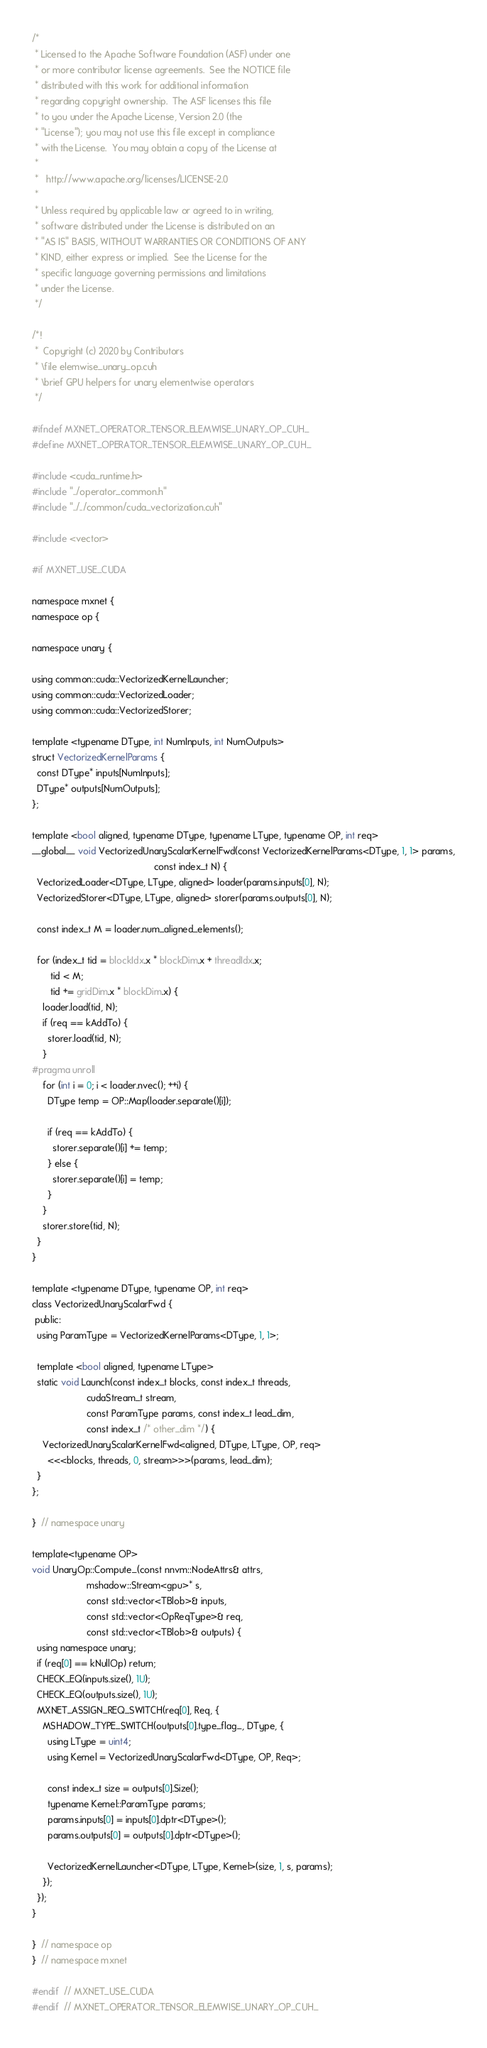Convert code to text. <code><loc_0><loc_0><loc_500><loc_500><_Cuda_>/*
 * Licensed to the Apache Software Foundation (ASF) under one
 * or more contributor license agreements.  See the NOTICE file
 * distributed with this work for additional information
 * regarding copyright ownership.  The ASF licenses this file
 * to you under the Apache License, Version 2.0 (the
 * "License"); you may not use this file except in compliance
 * with the License.  You may obtain a copy of the License at
 *
 *   http://www.apache.org/licenses/LICENSE-2.0
 *
 * Unless required by applicable law or agreed to in writing,
 * software distributed under the License is distributed on an
 * "AS IS" BASIS, WITHOUT WARRANTIES OR CONDITIONS OF ANY
 * KIND, either express or implied.  See the License for the
 * specific language governing permissions and limitations
 * under the License.
 */

/*!
 *  Copyright (c) 2020 by Contributors
 * \file elemwise_unary_op.cuh
 * \brief GPU helpers for unary elementwise operators
 */

#ifndef MXNET_OPERATOR_TENSOR_ELEMWISE_UNARY_OP_CUH_
#define MXNET_OPERATOR_TENSOR_ELEMWISE_UNARY_OP_CUH_

#include <cuda_runtime.h>
#include "../operator_common.h"
#include "../../common/cuda_vectorization.cuh"

#include <vector>

#if MXNET_USE_CUDA

namespace mxnet {
namespace op {

namespace unary {

using common::cuda::VectorizedKernelLauncher;
using common::cuda::VectorizedLoader;
using common::cuda::VectorizedStorer;

template <typename DType, int NumInputs, int NumOutputs>
struct VectorizedKernelParams {
  const DType* inputs[NumInputs];
  DType* outputs[NumOutputs];
};

template <bool aligned, typename DType, typename LType, typename OP, int req>
__global__ void VectorizedUnaryScalarKernelFwd(const VectorizedKernelParams<DType, 1, 1> params,
                                               const index_t N) {
  VectorizedLoader<DType, LType, aligned> loader(params.inputs[0], N);
  VectorizedStorer<DType, LType, aligned> storer(params.outputs[0], N);

  const index_t M = loader.num_aligned_elements();

  for (index_t tid = blockIdx.x * blockDim.x + threadIdx.x;
       tid < M;
       tid += gridDim.x * blockDim.x) {
    loader.load(tid, N);
    if (req == kAddTo) {
      storer.load(tid, N);
    }
#pragma unroll
    for (int i = 0; i < loader.nvec(); ++i) {
      DType temp = OP::Map(loader.separate()[i]);

      if (req == kAddTo) {
        storer.separate()[i] += temp;
      } else {
        storer.separate()[i] = temp;
      }
    }
    storer.store(tid, N);
  }
}

template <typename DType, typename OP, int req>
class VectorizedUnaryScalarFwd {
 public:
  using ParamType = VectorizedKernelParams<DType, 1, 1>;

  template <bool aligned, typename LType>
  static void Launch(const index_t blocks, const index_t threads,
                     cudaStream_t stream,
                     const ParamType params, const index_t lead_dim,
                     const index_t /* other_dim */) {
    VectorizedUnaryScalarKernelFwd<aligned, DType, LType, OP, req>
      <<<blocks, threads, 0, stream>>>(params, lead_dim);
  }
};

}  // namespace unary

template<typename OP>
void UnaryOp::Compute_(const nnvm::NodeAttrs& attrs,
                     mshadow::Stream<gpu>* s,
                     const std::vector<TBlob>& inputs,
                     const std::vector<OpReqType>& req,
                     const std::vector<TBlob>& outputs) {
  using namespace unary;
  if (req[0] == kNullOp) return;
  CHECK_EQ(inputs.size(), 1U);
  CHECK_EQ(outputs.size(), 1U);
  MXNET_ASSIGN_REQ_SWITCH(req[0], Req, {
    MSHADOW_TYPE_SWITCH(outputs[0].type_flag_, DType, {
      using LType = uint4;
      using Kernel = VectorizedUnaryScalarFwd<DType, OP, Req>;

      const index_t size = outputs[0].Size();
      typename Kernel::ParamType params;
      params.inputs[0] = inputs[0].dptr<DType>();
      params.outputs[0] = outputs[0].dptr<DType>();

      VectorizedKernelLauncher<DType, LType, Kernel>(size, 1, s, params);
    });
  });
}

}  // namespace op
}  // namespace mxnet

#endif  // MXNET_USE_CUDA
#endif  // MXNET_OPERATOR_TENSOR_ELEMWISE_UNARY_OP_CUH_
</code> 